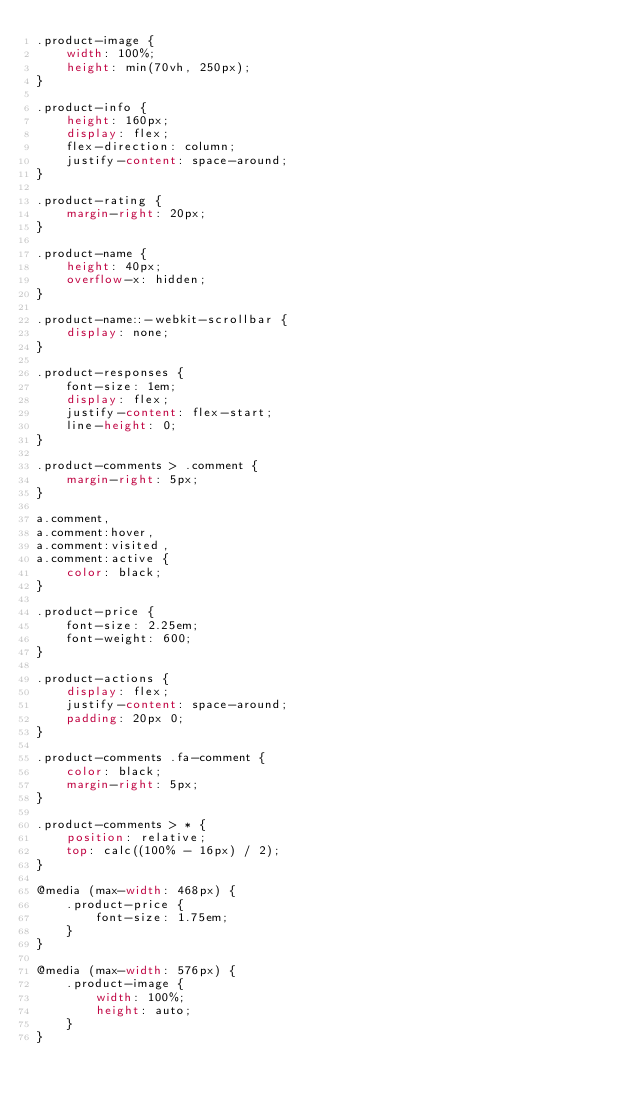<code> <loc_0><loc_0><loc_500><loc_500><_CSS_>.product-image {
    width: 100%;
    height: min(70vh, 250px);
}

.product-info {
    height: 160px;
    display: flex;
    flex-direction: column;
    justify-content: space-around;
}

.product-rating {
    margin-right: 20px;
}

.product-name {
    height: 40px;
    overflow-x: hidden;
}

.product-name::-webkit-scrollbar {
    display: none;
}

.product-responses {
    font-size: 1em;
    display: flex;
    justify-content: flex-start;
    line-height: 0;
}

.product-comments > .comment {
    margin-right: 5px;
}

a.comment,
a.comment:hover,
a.comment:visited,
a.comment:active {
    color: black;
}

.product-price {
    font-size: 2.25em;
    font-weight: 600;
}

.product-actions {
    display: flex;
    justify-content: space-around;
    padding: 20px 0;
}

.product-comments .fa-comment {
    color: black;
    margin-right: 5px;
}

.product-comments > * {
    position: relative;
    top: calc((100% - 16px) / 2);
}

@media (max-width: 468px) {
    .product-price {
        font-size: 1.75em;
    }
}

@media (max-width: 576px) {
    .product-image {
        width: 100%;
        height: auto;
    }
}
</code> 